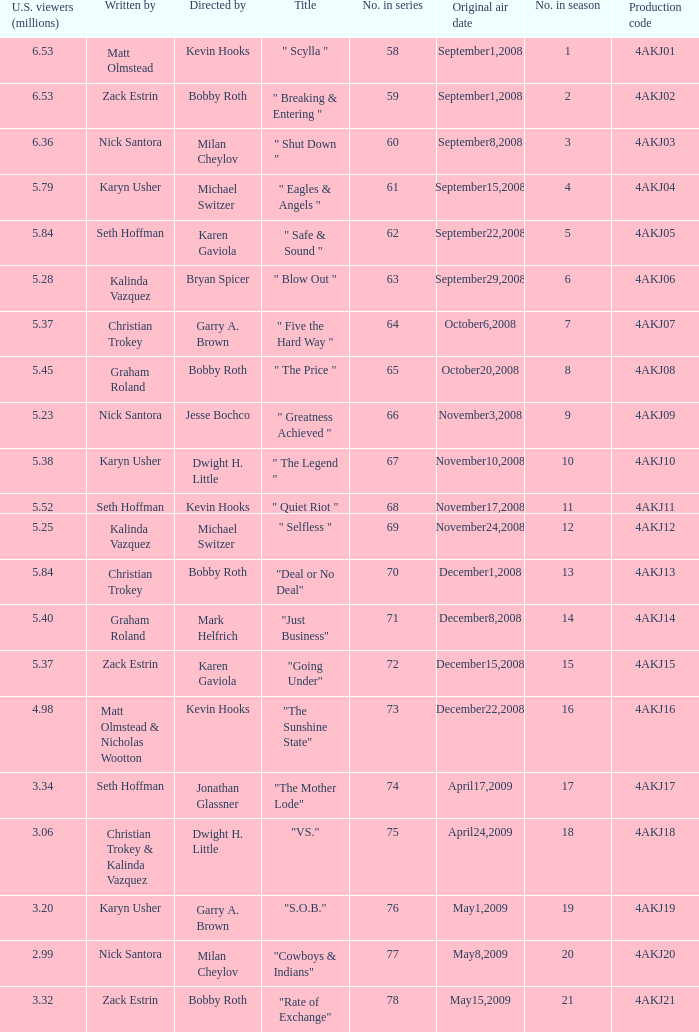Who directed the episode with production code 4akj01? Kevin Hooks. 